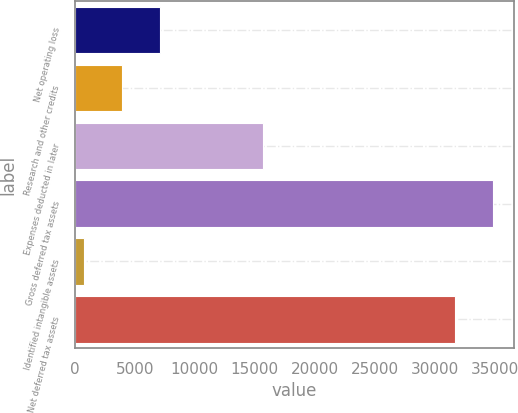Convert chart. <chart><loc_0><loc_0><loc_500><loc_500><bar_chart><fcel>Net operating loss<fcel>Research and other credits<fcel>Expenses deducted in later<fcel>Gross deferred tax assets<fcel>Identified intangible assets<fcel>Net deferred tax assets<nl><fcel>7129.4<fcel>3961.7<fcel>15735<fcel>34844.7<fcel>794<fcel>31677<nl></chart> 